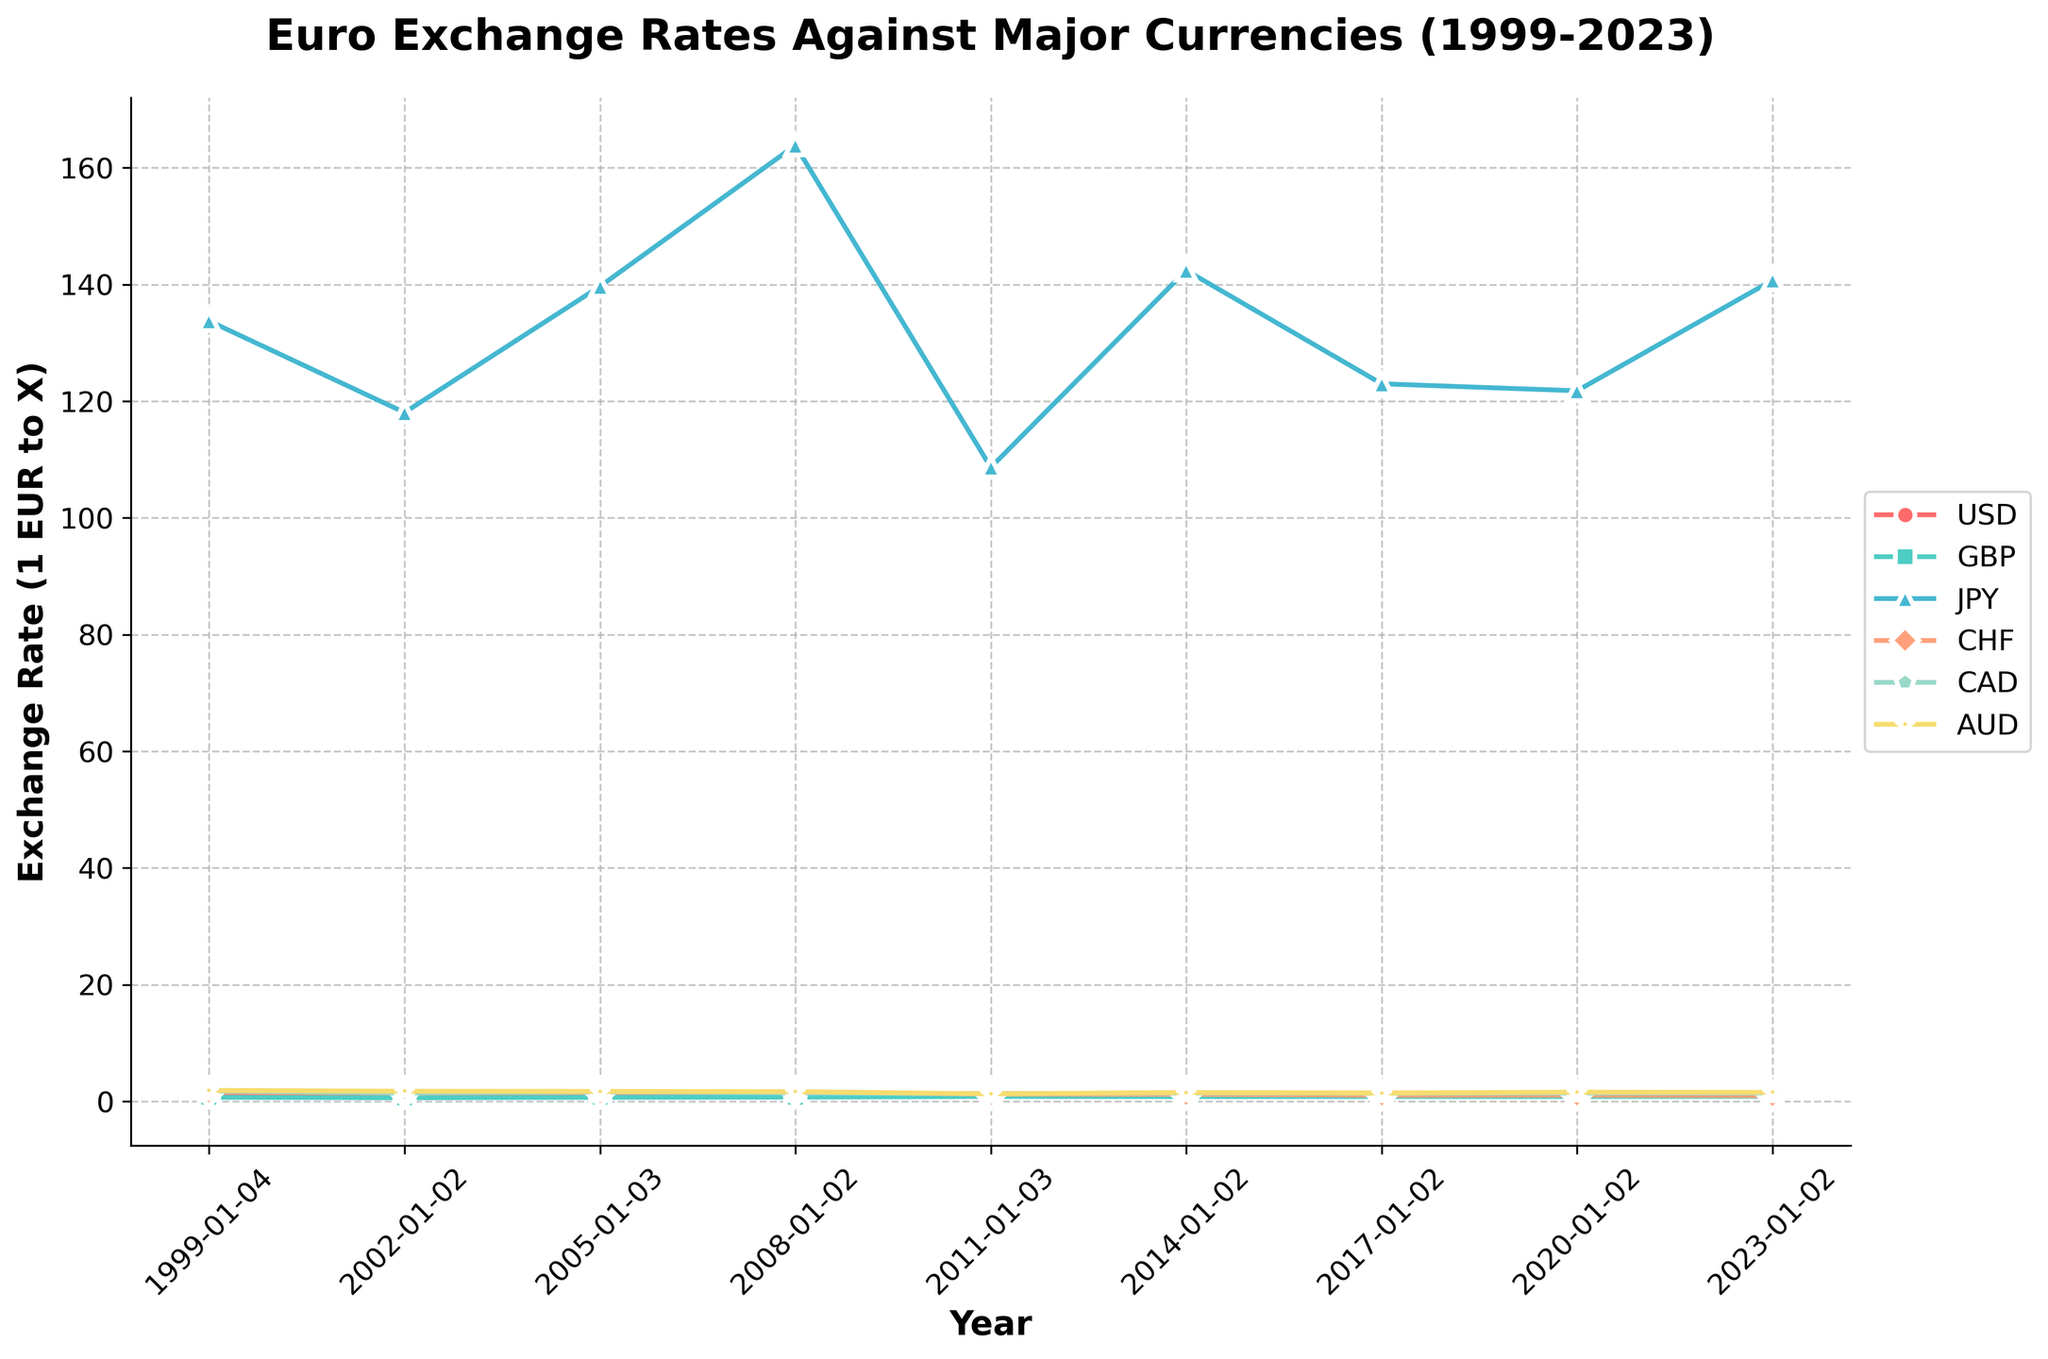Which currency experienced the highest exchange rate against the Euro in 2023? Looking at the data for 2023, the Japanese Yen (JPY) has the highest numerical value compared to other currencies against the Euro.
Answer: JPY How did the exchange rate of the Euro against the USD change from 1999 to 2023? In 1999, the exchange rate of the Euro against the USD was 1.1789. By 2023, it decreased to 1.0693. Therefore, the exchange rate declined over this period.
Answer: Decreased Which currency showed the most significant decrease in exchange rate value against the Euro from 1999 to 2023? By comparing the exchange rates over time, the Swiss Franc (CHF) had a notable decrease from 1.6123 in 1999 to 0.9889 in 2023.
Answer: CHF What is the average exchange rate of the Euro to CAD from 1999 to 2023? Summing the exchange rates for CAD across the years (1.8123, 1.4338, 1.6416, 1.4584, 1.3284, 1.4569, 1.4047, 1.4561, 1.4473) and dividing by the number of years (9), the average is (13.4395 / 9).
Answer: 1.4932 Between which two years did the Euro experience the most significant increase in exchange rate against GBP? By visually inspecting the chart, the most significant increase occurs between 2008 (0.7367) and 2011 (0.8577).
Answer: 2008 to 2011 In what year did the Euro have the lowest exchange rate against the AUD? The lowest numerical value for the AUD occurs in 2011, where the exchange rate is 1.3137.
Answer: 2011 Which year had the smallest exchange rate discrepancy between the Euro and USD? Looking at the differences over the years, the year 2017 had the smallest value (1.0454).
Answer: 2017 How does the exchange rate of the Euro to JPY in 2011 compare to that in 2002? In 2011, the exchange rate to JPY was 108.65, while in 2002 it was 118.05. The 2011 rate is smaller.
Answer: Smaller What is the trend of the Euro against the CHF from 1999 to 2023? Starting from 1.6123 in 1999, the trend generally decreases to 0.9889 in 2023, indicating a downward trend.
Answer: Downward How many times did the exchange rate of the Euro to GBP increase across the entire timeline? The Euro to GBP exchange rate increased from 1999 to 2005, 2008 to 2011, and 2020 to 2023. This is a total of 3 increases.
Answer: 3 